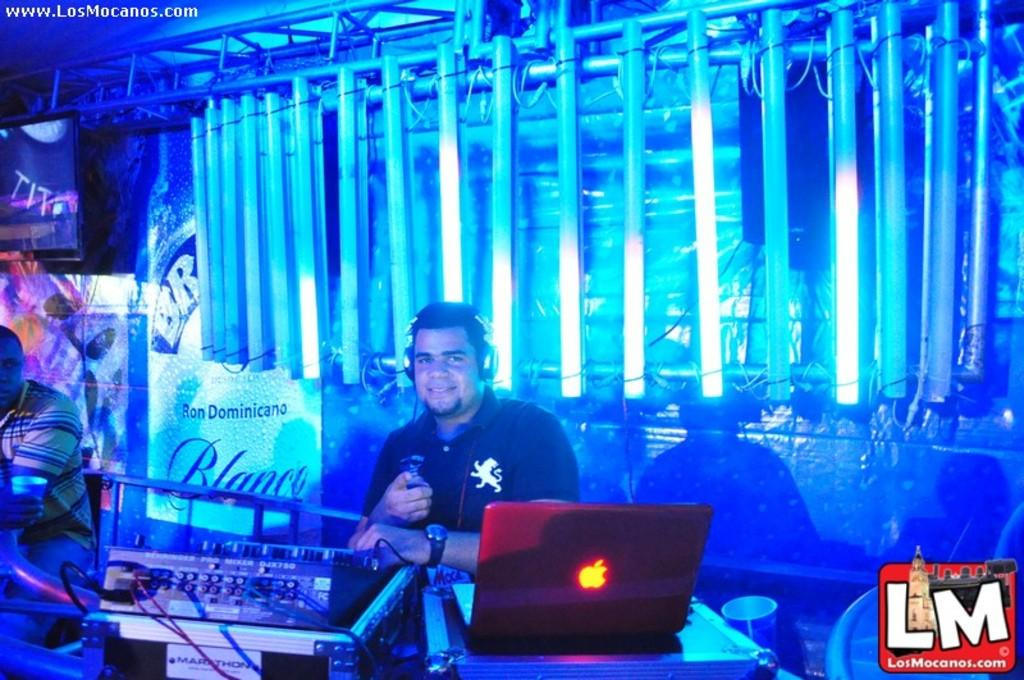<image>
Offer a succinct explanation of the picture presented. A dj posing for the website losmocanos.com in a night club. 